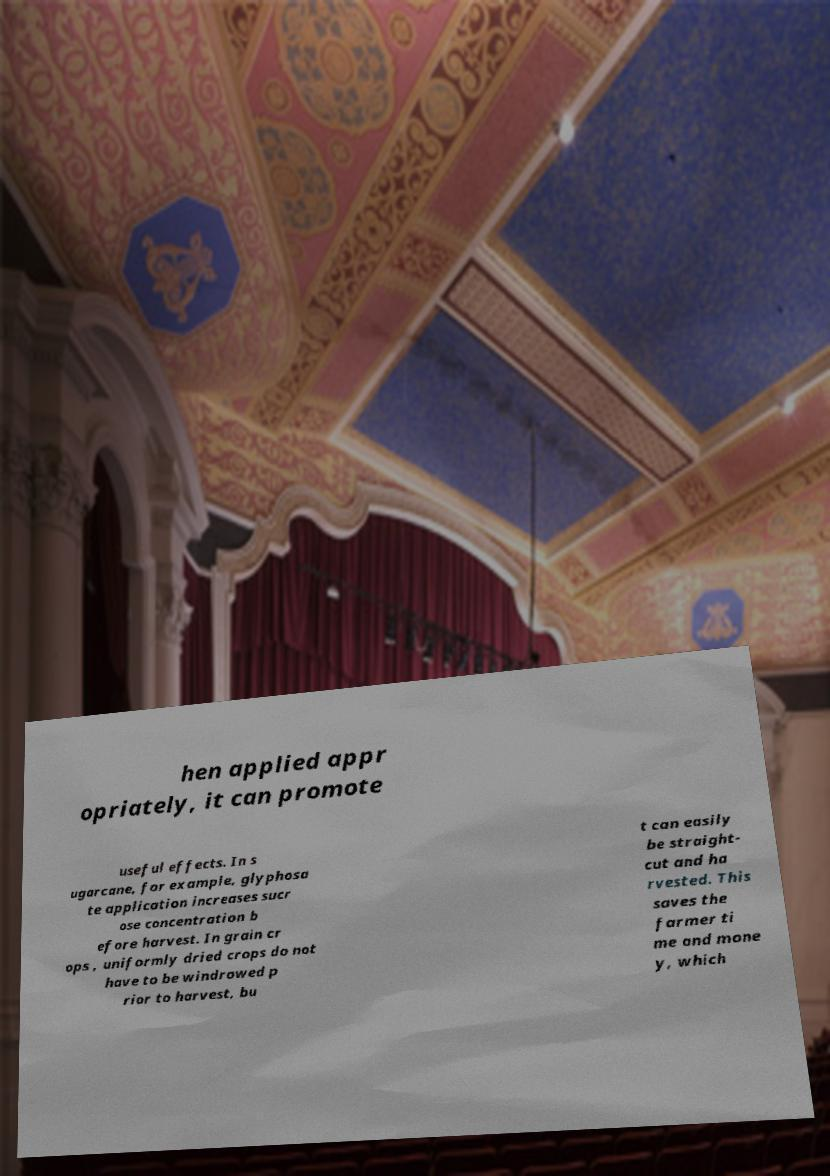Could you extract and type out the text from this image? hen applied appr opriately, it can promote useful effects. In s ugarcane, for example, glyphosa te application increases sucr ose concentration b efore harvest. In grain cr ops , uniformly dried crops do not have to be windrowed p rior to harvest, bu t can easily be straight- cut and ha rvested. This saves the farmer ti me and mone y, which 